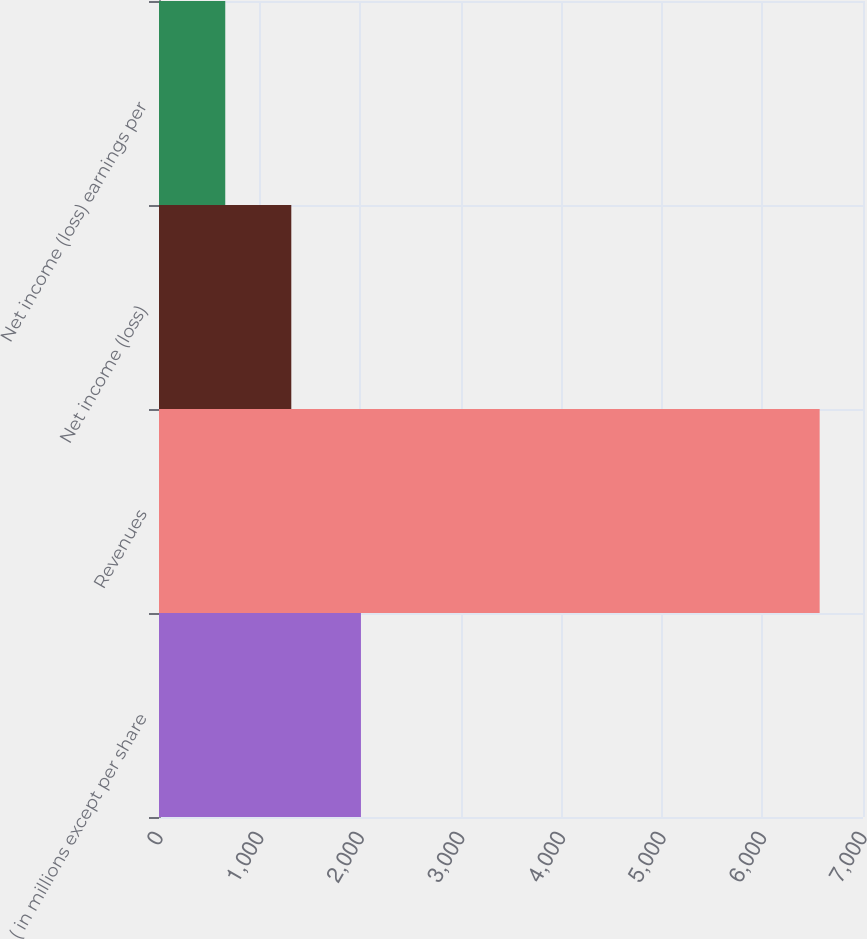Convert chart to OTSL. <chart><loc_0><loc_0><loc_500><loc_500><bar_chart><fcel>( in millions except per share<fcel>Revenues<fcel>Net income (loss)<fcel>Net income (loss) earnings per<nl><fcel>2008<fcel>6569<fcel>1315.49<fcel>658.8<nl></chart> 